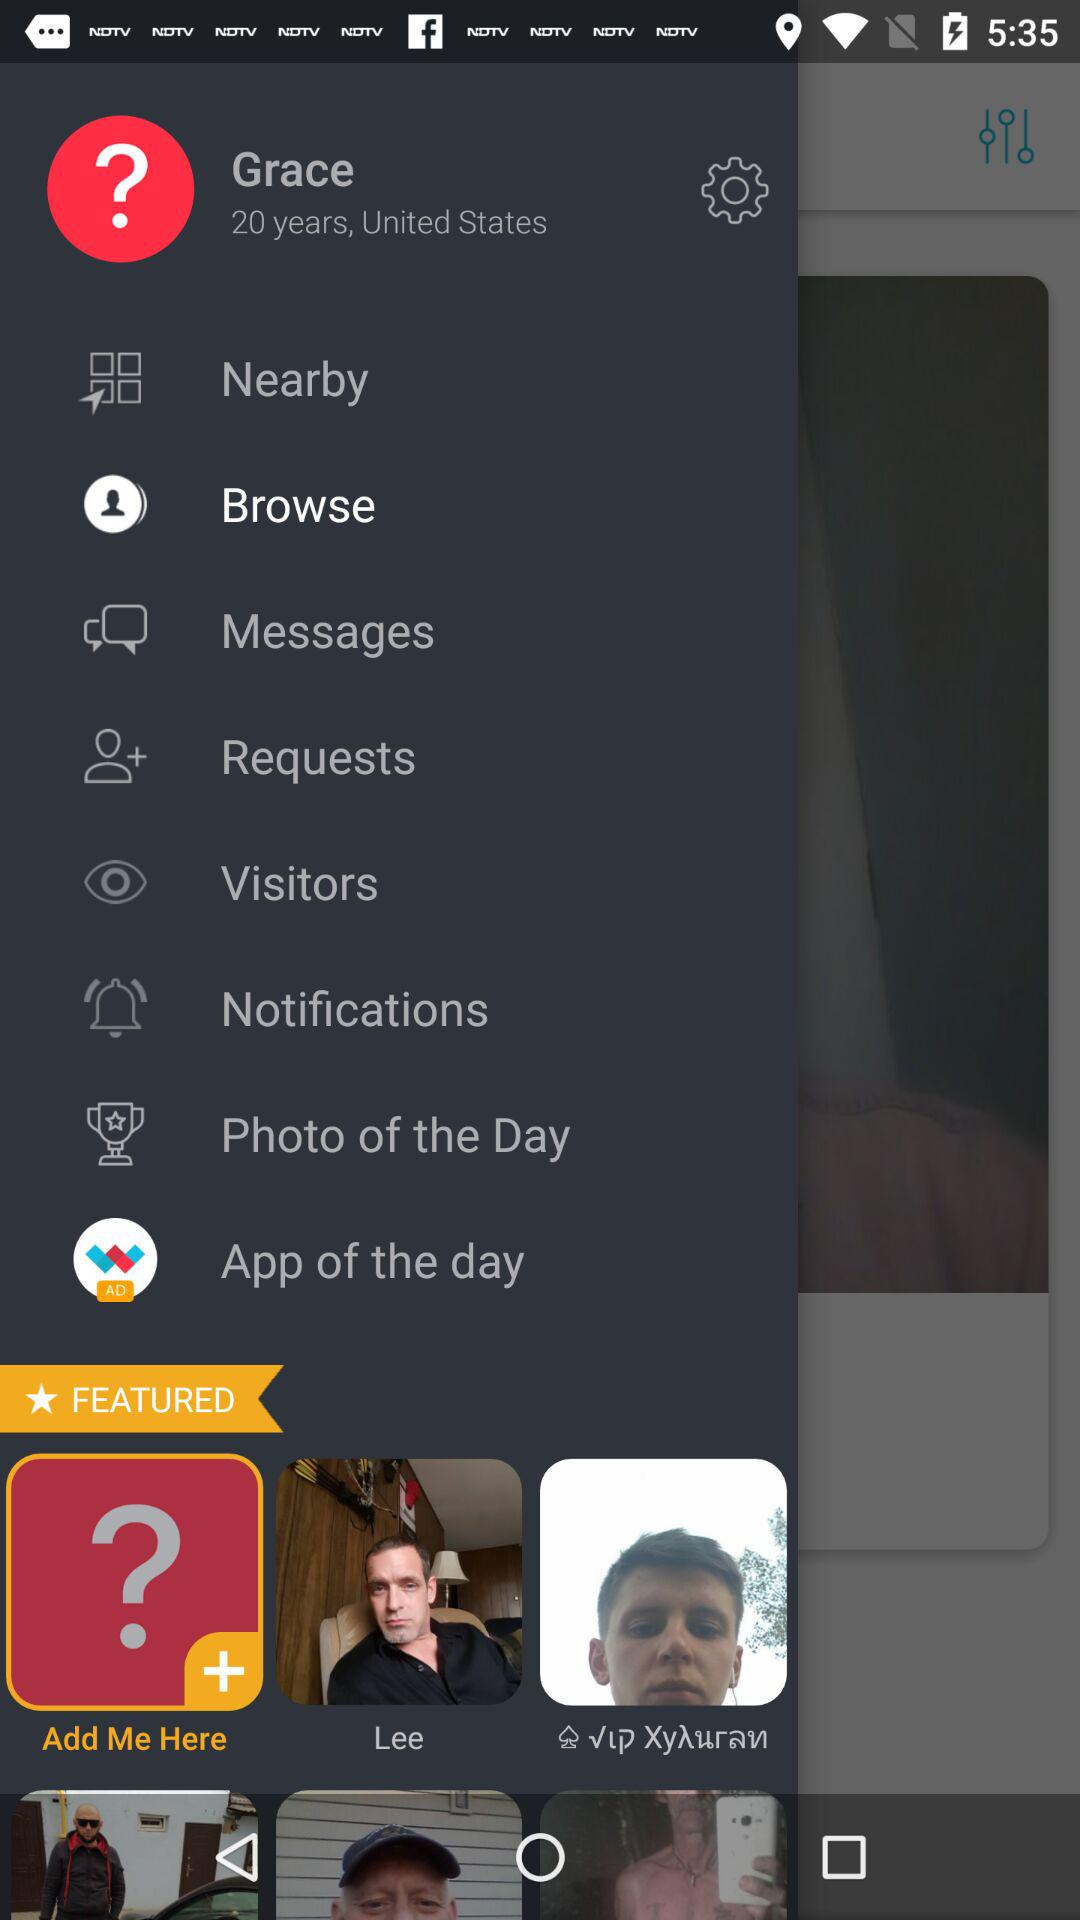Where did Grace live? Grace lived in the United States. 